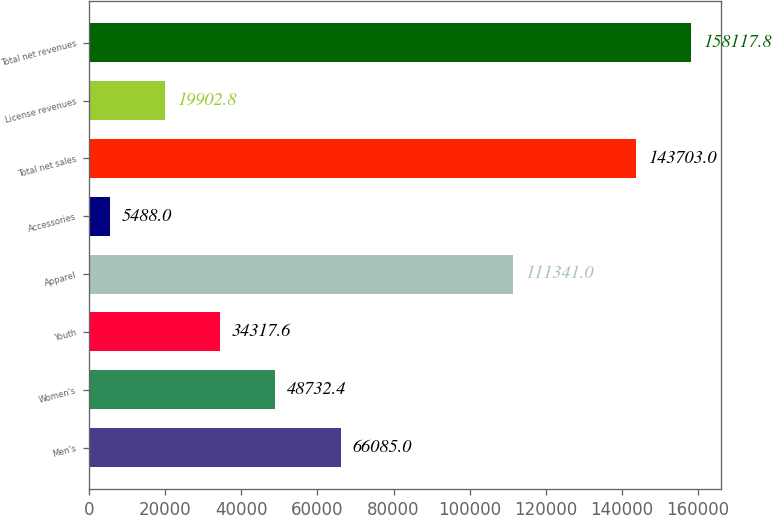<chart> <loc_0><loc_0><loc_500><loc_500><bar_chart><fcel>Men's<fcel>Women's<fcel>Youth<fcel>Apparel<fcel>Accessories<fcel>Total net sales<fcel>License revenues<fcel>Total net revenues<nl><fcel>66085<fcel>48732.4<fcel>34317.6<fcel>111341<fcel>5488<fcel>143703<fcel>19902.8<fcel>158118<nl></chart> 